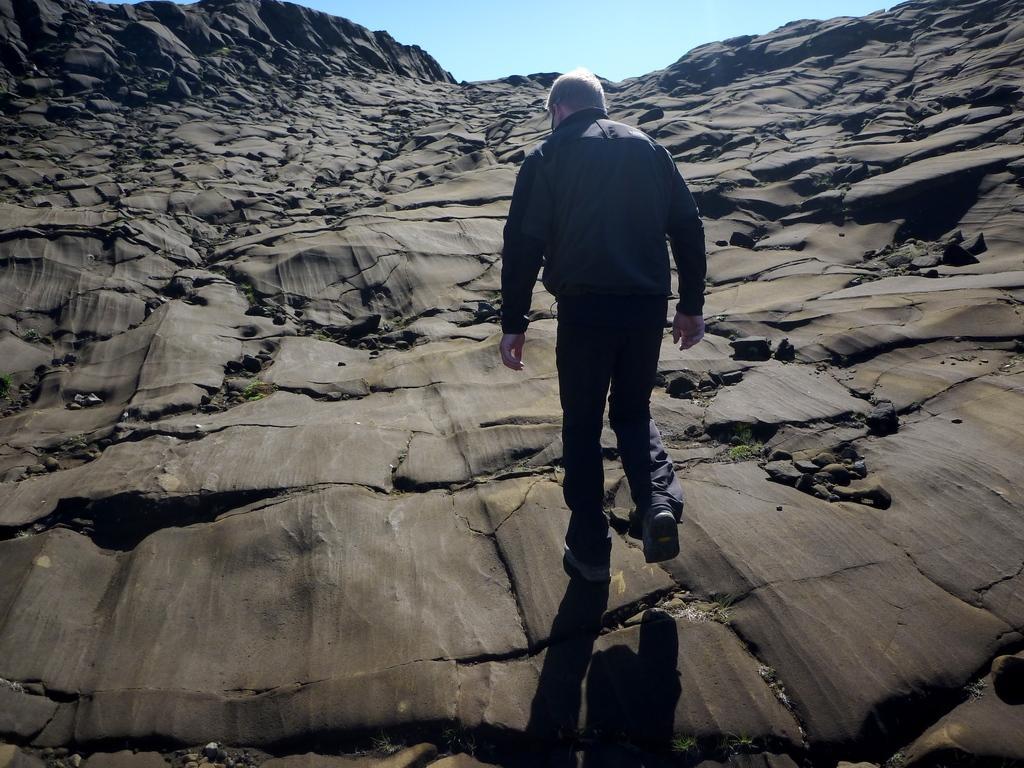In one or two sentences, can you explain what this image depicts? This image consists of a man walking. He is wearing a blue dress. At the bottom, there are rocks. At the top, there is sky. 